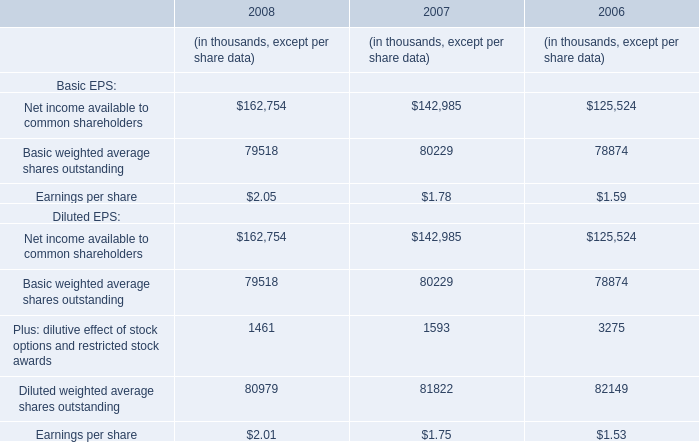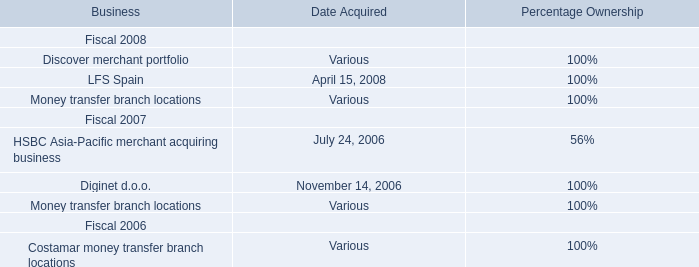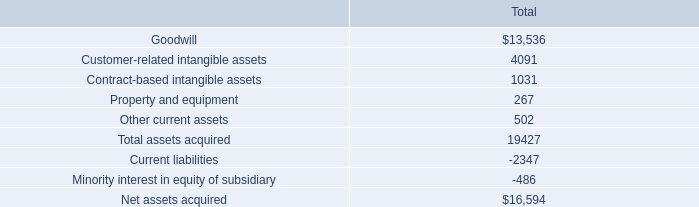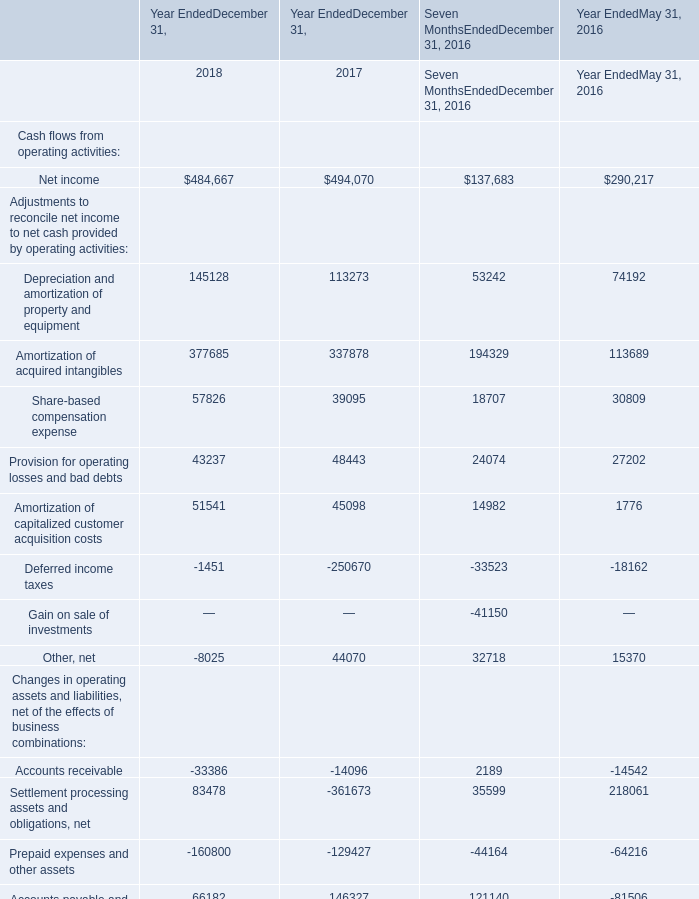what percentage of net assets acquired was considered goodwill? 
Computations: (13536 / 16594)
Answer: 0.81572. 